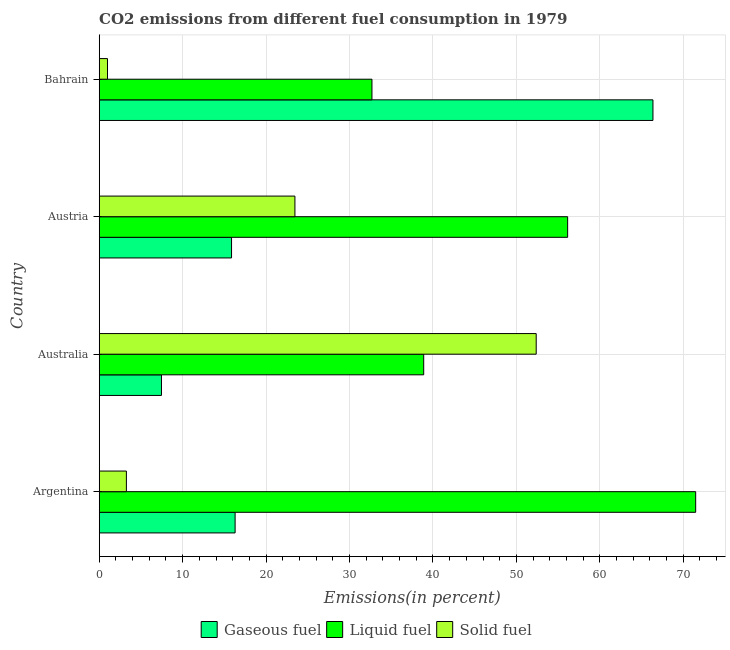How many groups of bars are there?
Give a very brief answer. 4. Are the number of bars on each tick of the Y-axis equal?
Your answer should be very brief. Yes. How many bars are there on the 1st tick from the top?
Provide a succinct answer. 3. What is the label of the 4th group of bars from the top?
Provide a short and direct response. Argentina. In how many cases, is the number of bars for a given country not equal to the number of legend labels?
Provide a succinct answer. 0. What is the percentage of gaseous fuel emission in Bahrain?
Your answer should be very brief. 66.37. Across all countries, what is the maximum percentage of gaseous fuel emission?
Make the answer very short. 66.37. Across all countries, what is the minimum percentage of liquid fuel emission?
Ensure brevity in your answer.  32.69. In which country was the percentage of gaseous fuel emission maximum?
Ensure brevity in your answer.  Bahrain. What is the total percentage of liquid fuel emission in the graph?
Your response must be concise. 199.21. What is the difference between the percentage of liquid fuel emission in Argentina and that in Australia?
Keep it short and to the point. 32.59. What is the difference between the percentage of gaseous fuel emission in Argentina and the percentage of liquid fuel emission in Australia?
Make the answer very short. -22.6. What is the average percentage of liquid fuel emission per country?
Your answer should be very brief. 49.8. What is the difference between the percentage of solid fuel emission and percentage of gaseous fuel emission in Australia?
Ensure brevity in your answer.  44.91. In how many countries, is the percentage of gaseous fuel emission greater than 24 %?
Your answer should be compact. 1. What is the ratio of the percentage of solid fuel emission in Argentina to that in Austria?
Your response must be concise. 0.14. What is the difference between the highest and the second highest percentage of liquid fuel emission?
Your answer should be very brief. 15.35. What is the difference between the highest and the lowest percentage of solid fuel emission?
Your answer should be very brief. 51.38. In how many countries, is the percentage of gaseous fuel emission greater than the average percentage of gaseous fuel emission taken over all countries?
Your answer should be compact. 1. What does the 1st bar from the top in Australia represents?
Offer a terse response. Solid fuel. What does the 2nd bar from the bottom in Bahrain represents?
Keep it short and to the point. Liquid fuel. Does the graph contain any zero values?
Provide a succinct answer. No. How many legend labels are there?
Give a very brief answer. 3. How are the legend labels stacked?
Offer a very short reply. Horizontal. What is the title of the graph?
Offer a very short reply. CO2 emissions from different fuel consumption in 1979. What is the label or title of the X-axis?
Your answer should be very brief. Emissions(in percent). What is the Emissions(in percent) of Gaseous fuel in Argentina?
Make the answer very short. 16.29. What is the Emissions(in percent) in Liquid fuel in Argentina?
Offer a terse response. 71.49. What is the Emissions(in percent) of Solid fuel in Argentina?
Provide a succinct answer. 3.26. What is the Emissions(in percent) of Gaseous fuel in Australia?
Make the answer very short. 7.46. What is the Emissions(in percent) of Liquid fuel in Australia?
Offer a terse response. 38.89. What is the Emissions(in percent) in Solid fuel in Australia?
Provide a short and direct response. 52.37. What is the Emissions(in percent) of Gaseous fuel in Austria?
Give a very brief answer. 15.86. What is the Emissions(in percent) in Liquid fuel in Austria?
Offer a very short reply. 56.14. What is the Emissions(in percent) of Solid fuel in Austria?
Your response must be concise. 23.46. What is the Emissions(in percent) of Gaseous fuel in Bahrain?
Make the answer very short. 66.37. What is the Emissions(in percent) of Liquid fuel in Bahrain?
Your answer should be compact. 32.69. What is the Emissions(in percent) of Solid fuel in Bahrain?
Keep it short and to the point. 0.99. Across all countries, what is the maximum Emissions(in percent) in Gaseous fuel?
Your answer should be compact. 66.37. Across all countries, what is the maximum Emissions(in percent) in Liquid fuel?
Your answer should be very brief. 71.49. Across all countries, what is the maximum Emissions(in percent) of Solid fuel?
Your answer should be very brief. 52.37. Across all countries, what is the minimum Emissions(in percent) of Gaseous fuel?
Your answer should be compact. 7.46. Across all countries, what is the minimum Emissions(in percent) of Liquid fuel?
Give a very brief answer. 32.69. Across all countries, what is the minimum Emissions(in percent) in Solid fuel?
Give a very brief answer. 0.99. What is the total Emissions(in percent) of Gaseous fuel in the graph?
Your answer should be very brief. 105.97. What is the total Emissions(in percent) in Liquid fuel in the graph?
Give a very brief answer. 199.21. What is the total Emissions(in percent) in Solid fuel in the graph?
Your answer should be very brief. 80.08. What is the difference between the Emissions(in percent) of Gaseous fuel in Argentina and that in Australia?
Ensure brevity in your answer.  8.83. What is the difference between the Emissions(in percent) in Liquid fuel in Argentina and that in Australia?
Offer a terse response. 32.6. What is the difference between the Emissions(in percent) in Solid fuel in Argentina and that in Australia?
Your answer should be compact. -49.12. What is the difference between the Emissions(in percent) in Gaseous fuel in Argentina and that in Austria?
Make the answer very short. 0.43. What is the difference between the Emissions(in percent) in Liquid fuel in Argentina and that in Austria?
Give a very brief answer. 15.35. What is the difference between the Emissions(in percent) of Solid fuel in Argentina and that in Austria?
Your response must be concise. -20.2. What is the difference between the Emissions(in percent) in Gaseous fuel in Argentina and that in Bahrain?
Give a very brief answer. -50.08. What is the difference between the Emissions(in percent) in Liquid fuel in Argentina and that in Bahrain?
Your answer should be very brief. 38.8. What is the difference between the Emissions(in percent) in Solid fuel in Argentina and that in Bahrain?
Give a very brief answer. 2.26. What is the difference between the Emissions(in percent) of Gaseous fuel in Australia and that in Austria?
Your answer should be compact. -8.4. What is the difference between the Emissions(in percent) in Liquid fuel in Australia and that in Austria?
Your response must be concise. -17.25. What is the difference between the Emissions(in percent) in Solid fuel in Australia and that in Austria?
Your response must be concise. 28.92. What is the difference between the Emissions(in percent) in Gaseous fuel in Australia and that in Bahrain?
Make the answer very short. -58.91. What is the difference between the Emissions(in percent) of Liquid fuel in Australia and that in Bahrain?
Make the answer very short. 6.2. What is the difference between the Emissions(in percent) in Solid fuel in Australia and that in Bahrain?
Give a very brief answer. 51.38. What is the difference between the Emissions(in percent) in Gaseous fuel in Austria and that in Bahrain?
Ensure brevity in your answer.  -50.51. What is the difference between the Emissions(in percent) in Liquid fuel in Austria and that in Bahrain?
Offer a very short reply. 23.45. What is the difference between the Emissions(in percent) in Solid fuel in Austria and that in Bahrain?
Offer a terse response. 22.46. What is the difference between the Emissions(in percent) of Gaseous fuel in Argentina and the Emissions(in percent) of Liquid fuel in Australia?
Provide a succinct answer. -22.6. What is the difference between the Emissions(in percent) in Gaseous fuel in Argentina and the Emissions(in percent) in Solid fuel in Australia?
Your response must be concise. -36.09. What is the difference between the Emissions(in percent) of Liquid fuel in Argentina and the Emissions(in percent) of Solid fuel in Australia?
Your response must be concise. 19.11. What is the difference between the Emissions(in percent) of Gaseous fuel in Argentina and the Emissions(in percent) of Liquid fuel in Austria?
Offer a terse response. -39.85. What is the difference between the Emissions(in percent) in Gaseous fuel in Argentina and the Emissions(in percent) in Solid fuel in Austria?
Keep it short and to the point. -7.17. What is the difference between the Emissions(in percent) of Liquid fuel in Argentina and the Emissions(in percent) of Solid fuel in Austria?
Offer a terse response. 48.03. What is the difference between the Emissions(in percent) of Gaseous fuel in Argentina and the Emissions(in percent) of Liquid fuel in Bahrain?
Offer a terse response. -16.4. What is the difference between the Emissions(in percent) in Gaseous fuel in Argentina and the Emissions(in percent) in Solid fuel in Bahrain?
Offer a very short reply. 15.3. What is the difference between the Emissions(in percent) of Liquid fuel in Argentina and the Emissions(in percent) of Solid fuel in Bahrain?
Your answer should be very brief. 70.49. What is the difference between the Emissions(in percent) of Gaseous fuel in Australia and the Emissions(in percent) of Liquid fuel in Austria?
Your answer should be compact. -48.68. What is the difference between the Emissions(in percent) in Gaseous fuel in Australia and the Emissions(in percent) in Solid fuel in Austria?
Your response must be concise. -16. What is the difference between the Emissions(in percent) in Liquid fuel in Australia and the Emissions(in percent) in Solid fuel in Austria?
Make the answer very short. 15.43. What is the difference between the Emissions(in percent) in Gaseous fuel in Australia and the Emissions(in percent) in Liquid fuel in Bahrain?
Provide a short and direct response. -25.23. What is the difference between the Emissions(in percent) of Gaseous fuel in Australia and the Emissions(in percent) of Solid fuel in Bahrain?
Give a very brief answer. 6.47. What is the difference between the Emissions(in percent) in Liquid fuel in Australia and the Emissions(in percent) in Solid fuel in Bahrain?
Keep it short and to the point. 37.9. What is the difference between the Emissions(in percent) in Gaseous fuel in Austria and the Emissions(in percent) in Liquid fuel in Bahrain?
Your answer should be very brief. -16.83. What is the difference between the Emissions(in percent) in Gaseous fuel in Austria and the Emissions(in percent) in Solid fuel in Bahrain?
Provide a succinct answer. 14.87. What is the difference between the Emissions(in percent) of Liquid fuel in Austria and the Emissions(in percent) of Solid fuel in Bahrain?
Provide a succinct answer. 55.15. What is the average Emissions(in percent) of Gaseous fuel per country?
Provide a short and direct response. 26.49. What is the average Emissions(in percent) of Liquid fuel per country?
Provide a short and direct response. 49.8. What is the average Emissions(in percent) of Solid fuel per country?
Give a very brief answer. 20.02. What is the difference between the Emissions(in percent) of Gaseous fuel and Emissions(in percent) of Liquid fuel in Argentina?
Give a very brief answer. -55.2. What is the difference between the Emissions(in percent) in Gaseous fuel and Emissions(in percent) in Solid fuel in Argentina?
Your answer should be very brief. 13.03. What is the difference between the Emissions(in percent) in Liquid fuel and Emissions(in percent) in Solid fuel in Argentina?
Your response must be concise. 68.23. What is the difference between the Emissions(in percent) of Gaseous fuel and Emissions(in percent) of Liquid fuel in Australia?
Give a very brief answer. -31.43. What is the difference between the Emissions(in percent) in Gaseous fuel and Emissions(in percent) in Solid fuel in Australia?
Your answer should be compact. -44.91. What is the difference between the Emissions(in percent) of Liquid fuel and Emissions(in percent) of Solid fuel in Australia?
Give a very brief answer. -13.48. What is the difference between the Emissions(in percent) of Gaseous fuel and Emissions(in percent) of Liquid fuel in Austria?
Ensure brevity in your answer.  -40.28. What is the difference between the Emissions(in percent) of Gaseous fuel and Emissions(in percent) of Solid fuel in Austria?
Provide a succinct answer. -7.6. What is the difference between the Emissions(in percent) in Liquid fuel and Emissions(in percent) in Solid fuel in Austria?
Provide a short and direct response. 32.68. What is the difference between the Emissions(in percent) of Gaseous fuel and Emissions(in percent) of Liquid fuel in Bahrain?
Your answer should be very brief. 33.68. What is the difference between the Emissions(in percent) in Gaseous fuel and Emissions(in percent) in Solid fuel in Bahrain?
Provide a succinct answer. 65.37. What is the difference between the Emissions(in percent) of Liquid fuel and Emissions(in percent) of Solid fuel in Bahrain?
Make the answer very short. 31.7. What is the ratio of the Emissions(in percent) in Gaseous fuel in Argentina to that in Australia?
Offer a terse response. 2.18. What is the ratio of the Emissions(in percent) of Liquid fuel in Argentina to that in Australia?
Keep it short and to the point. 1.84. What is the ratio of the Emissions(in percent) of Solid fuel in Argentina to that in Australia?
Keep it short and to the point. 0.06. What is the ratio of the Emissions(in percent) in Gaseous fuel in Argentina to that in Austria?
Provide a short and direct response. 1.03. What is the ratio of the Emissions(in percent) of Liquid fuel in Argentina to that in Austria?
Your answer should be compact. 1.27. What is the ratio of the Emissions(in percent) in Solid fuel in Argentina to that in Austria?
Provide a succinct answer. 0.14. What is the ratio of the Emissions(in percent) of Gaseous fuel in Argentina to that in Bahrain?
Your answer should be compact. 0.25. What is the ratio of the Emissions(in percent) of Liquid fuel in Argentina to that in Bahrain?
Offer a terse response. 2.19. What is the ratio of the Emissions(in percent) of Solid fuel in Argentina to that in Bahrain?
Offer a terse response. 3.28. What is the ratio of the Emissions(in percent) in Gaseous fuel in Australia to that in Austria?
Your answer should be very brief. 0.47. What is the ratio of the Emissions(in percent) in Liquid fuel in Australia to that in Austria?
Offer a very short reply. 0.69. What is the ratio of the Emissions(in percent) of Solid fuel in Australia to that in Austria?
Keep it short and to the point. 2.23. What is the ratio of the Emissions(in percent) in Gaseous fuel in Australia to that in Bahrain?
Keep it short and to the point. 0.11. What is the ratio of the Emissions(in percent) in Liquid fuel in Australia to that in Bahrain?
Give a very brief answer. 1.19. What is the ratio of the Emissions(in percent) in Solid fuel in Australia to that in Bahrain?
Offer a terse response. 52.8. What is the ratio of the Emissions(in percent) of Gaseous fuel in Austria to that in Bahrain?
Give a very brief answer. 0.24. What is the ratio of the Emissions(in percent) in Liquid fuel in Austria to that in Bahrain?
Make the answer very short. 1.72. What is the ratio of the Emissions(in percent) of Solid fuel in Austria to that in Bahrain?
Provide a succinct answer. 23.65. What is the difference between the highest and the second highest Emissions(in percent) in Gaseous fuel?
Ensure brevity in your answer.  50.08. What is the difference between the highest and the second highest Emissions(in percent) of Liquid fuel?
Provide a short and direct response. 15.35. What is the difference between the highest and the second highest Emissions(in percent) in Solid fuel?
Provide a short and direct response. 28.92. What is the difference between the highest and the lowest Emissions(in percent) in Gaseous fuel?
Offer a very short reply. 58.91. What is the difference between the highest and the lowest Emissions(in percent) in Liquid fuel?
Offer a very short reply. 38.8. What is the difference between the highest and the lowest Emissions(in percent) in Solid fuel?
Offer a terse response. 51.38. 